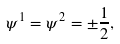<formula> <loc_0><loc_0><loc_500><loc_500>\psi ^ { 1 } = \psi ^ { 2 } = \pm \frac { 1 } { 2 } ,</formula> 